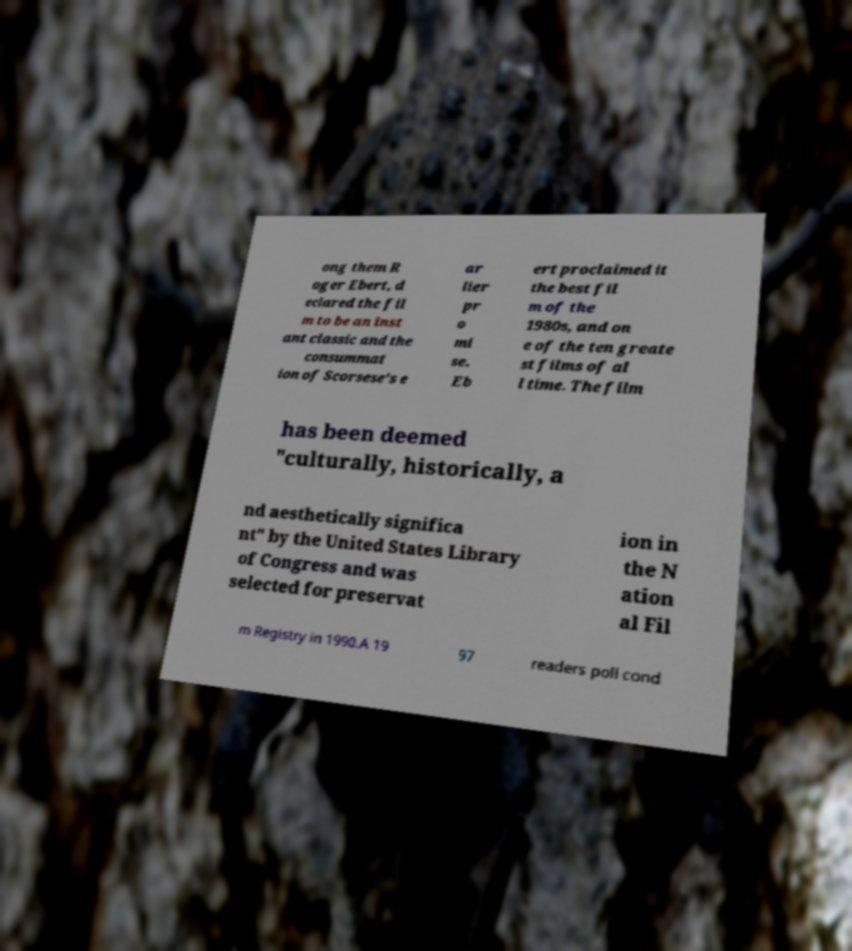Could you assist in decoding the text presented in this image and type it out clearly? ong them R oger Ebert, d eclared the fil m to be an inst ant classic and the consummat ion of Scorsese's e ar lier pr o mi se. Eb ert proclaimed it the best fil m of the 1980s, and on e of the ten greate st films of al l time. The film has been deemed "culturally, historically, a nd aesthetically significa nt" by the United States Library of Congress and was selected for preservat ion in the N ation al Fil m Registry in 1990.A 19 97 readers poll cond 